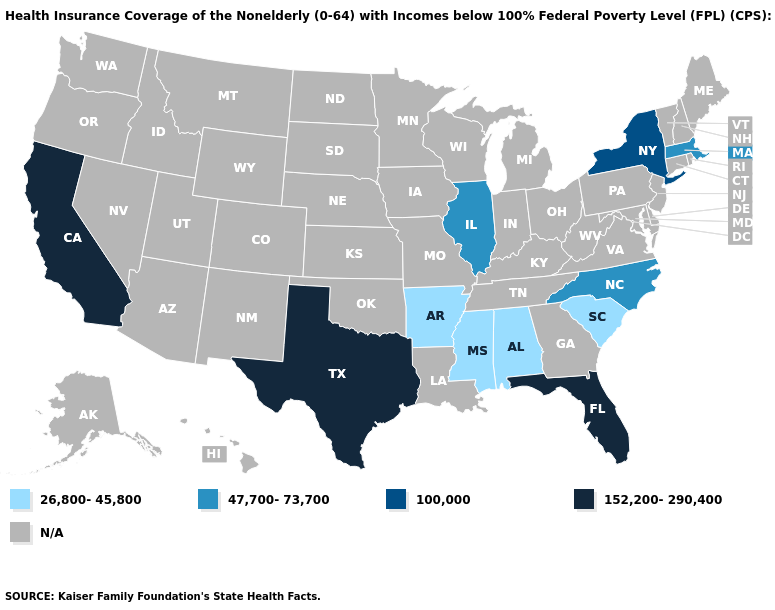Does the map have missing data?
Answer briefly. Yes. Which states have the lowest value in the MidWest?
Answer briefly. Illinois. How many symbols are there in the legend?
Keep it brief. 5. Does New York have the lowest value in the Northeast?
Be succinct. No. Does North Carolina have the highest value in the USA?
Answer briefly. No. Is the legend a continuous bar?
Quick response, please. No. Among the states that border Louisiana , does Texas have the highest value?
Write a very short answer. Yes. What is the highest value in the USA?
Short answer required. 152,200-290,400. What is the lowest value in the USA?
Concise answer only. 26,800-45,800. Which states hav the highest value in the MidWest?
Keep it brief. Illinois. What is the lowest value in the MidWest?
Quick response, please. 47,700-73,700. What is the value of Mississippi?
Concise answer only. 26,800-45,800. What is the value of Maine?
Be succinct. N/A. 